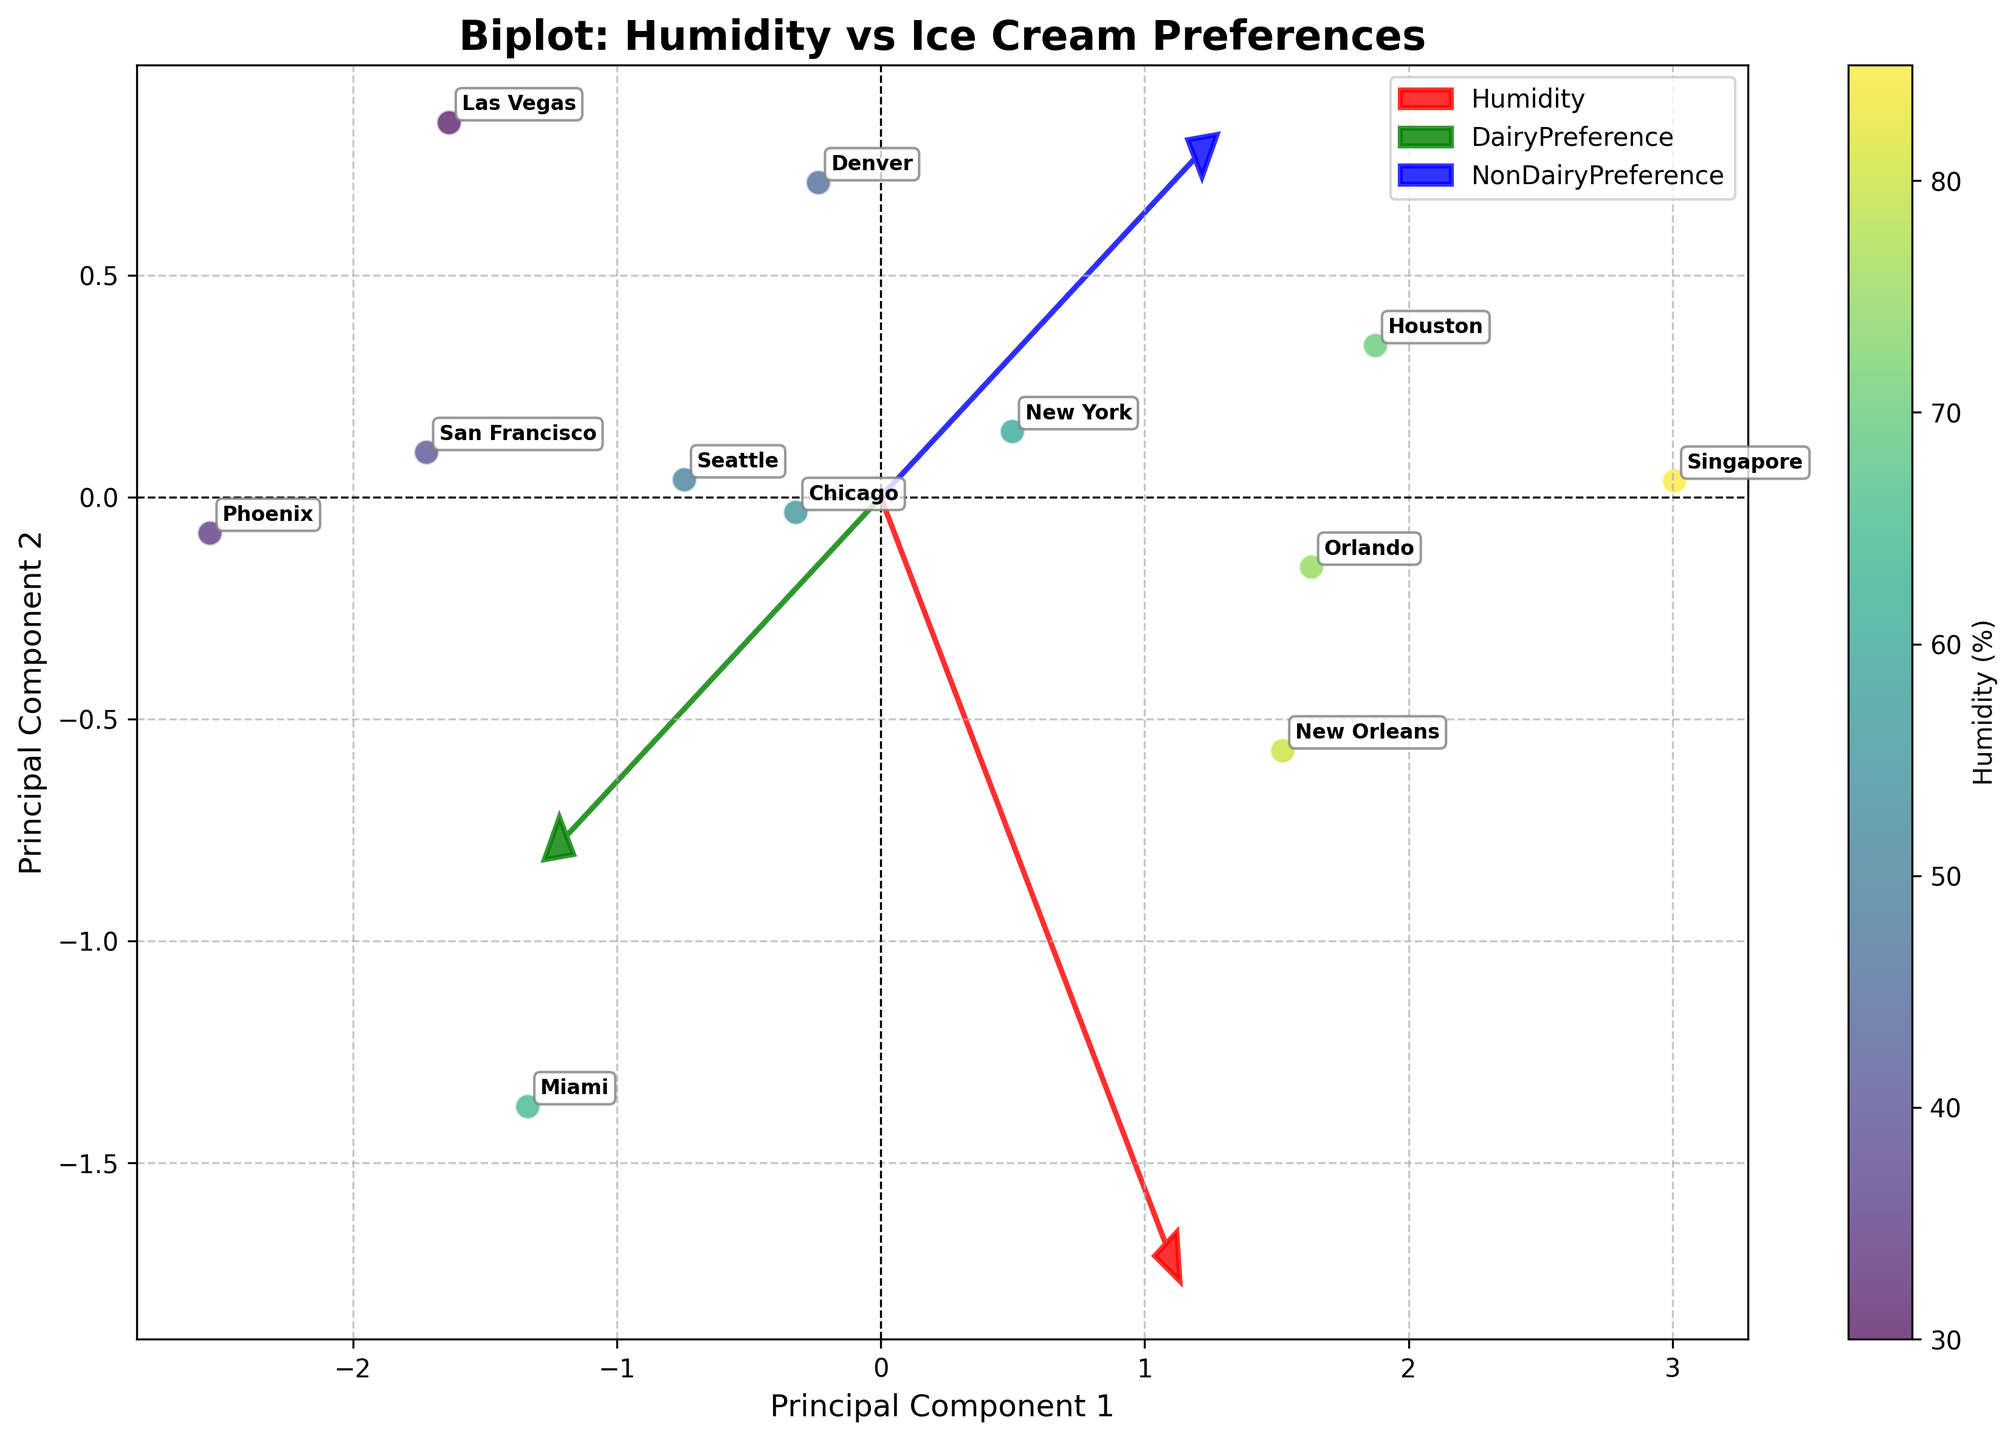What is the title of the plot? The title of the plot can be found at the top of the figure, labeled "Biplot: Humidity vs Ice Cream Preferences".
Answer: Biplot: Humidity vs Ice Cream Preferences How many cities are labeled in the plot? The plot annotates each data point with the name of the city it represents. By counting these annotations, you can determine there are 12 cities labeled in the plot.
Answer: 12 Which city shows the highest preference for dairy ice cream? The plot shows vectors for "DairyPreference" and annotated city points. Phoenix, annotated near the end of the "DairyPreference" vector, has the highest preference for dairy ice cream.
Answer: Phoenix What is the relationship between humidity and non-dairy ice cream preference? To analyze this, look at the direction and proximity of the "Humidity" and "NonDairyPreference" vectors. The closer and more aligned they are, the stronger the relationship. Since they are somewhat aligned, a moderate positive relationship is indicated.
Answer: Moderate positive relationship Compare the dairy and non-dairy ice cream preferences in Miami. Which is higher? The position of Miami relative to the "DairyPreference" and "NonDairyPreference" vectors shows it is closer to the "DairyPreference" vector, indicating a higher preference for dairy ice cream.
Answer: Dairy ice cream Which principal component seems to explain more variance, PC1 or PC2? By examining the spread of the data points along the principal components, the spread is greater along PC1, indicating it captures more variance.
Answer: PC1 What does the length and direction of the "Humidity" vector suggest? In a biplot, longer vectors indicate more significant variables. The "Humidity" vector's longer length and spread correlation with the first principal component suggest it is a significant variable with considerable impact on variance.
Answer: Significant variable How does the preference for non-dairy ice cream in Singapore compare to other cities? Singapore's position near the "NonDairyPreference" vector's positive direction means it has one of the higher preferences for non-dairy ice cream compared to other cities.
Answer: Higher preference Is there an observable trend between cities with higher humidity and their ice cream preference? By looking at the "Humidity" vector and the positions of cities annotated along it, cities with higher humidity (e.g., Singapore, New Orleans) lean closer to the "NonDairyPreference" vector, indicating greater non-dairy ice cream preference.
Answer: Higher humidity, greater non-dairy preference How does the dairy ice cream preference in Denver compare to Chicago? Denver and Chicago’s positions relative to the "DairyPreference" vector show that Denver is closer to the origin, indicating a lower preference, while Chicago is farther along, indicating a higher dairy preference.
Answer: Chicago has a higher dairy preference 